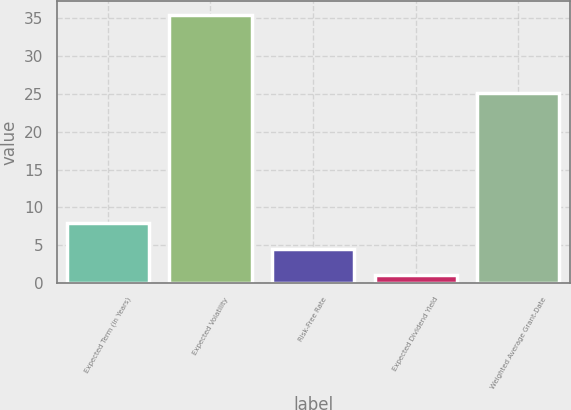<chart> <loc_0><loc_0><loc_500><loc_500><bar_chart><fcel>Expected Term (in Years)<fcel>Expected Volatility<fcel>Risk-Free Rate<fcel>Expected Dividend Yield<fcel>Weighted Average Grant-Date<nl><fcel>7.96<fcel>35.4<fcel>4.53<fcel>1.1<fcel>25.05<nl></chart> 